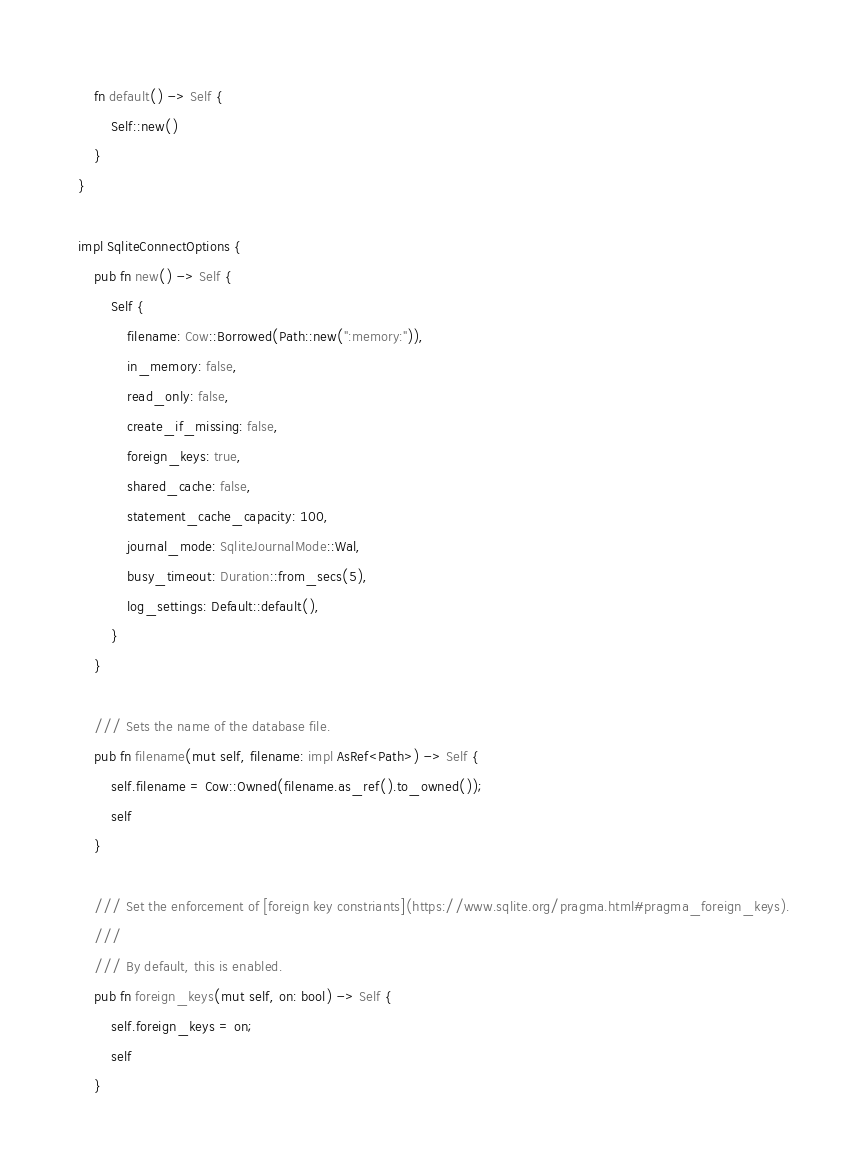<code> <loc_0><loc_0><loc_500><loc_500><_Rust_>    fn default() -> Self {
        Self::new()
    }
}

impl SqliteConnectOptions {
    pub fn new() -> Self {
        Self {
            filename: Cow::Borrowed(Path::new(":memory:")),
            in_memory: false,
            read_only: false,
            create_if_missing: false,
            foreign_keys: true,
            shared_cache: false,
            statement_cache_capacity: 100,
            journal_mode: SqliteJournalMode::Wal,
            busy_timeout: Duration::from_secs(5),
            log_settings: Default::default(),
        }
    }

    /// Sets the name of the database file.
    pub fn filename(mut self, filename: impl AsRef<Path>) -> Self {
        self.filename = Cow::Owned(filename.as_ref().to_owned());
        self
    }

    /// Set the enforcement of [foreign key constriants](https://www.sqlite.org/pragma.html#pragma_foreign_keys).
    ///
    /// By default, this is enabled.
    pub fn foreign_keys(mut self, on: bool) -> Self {
        self.foreign_keys = on;
        self
    }
</code> 